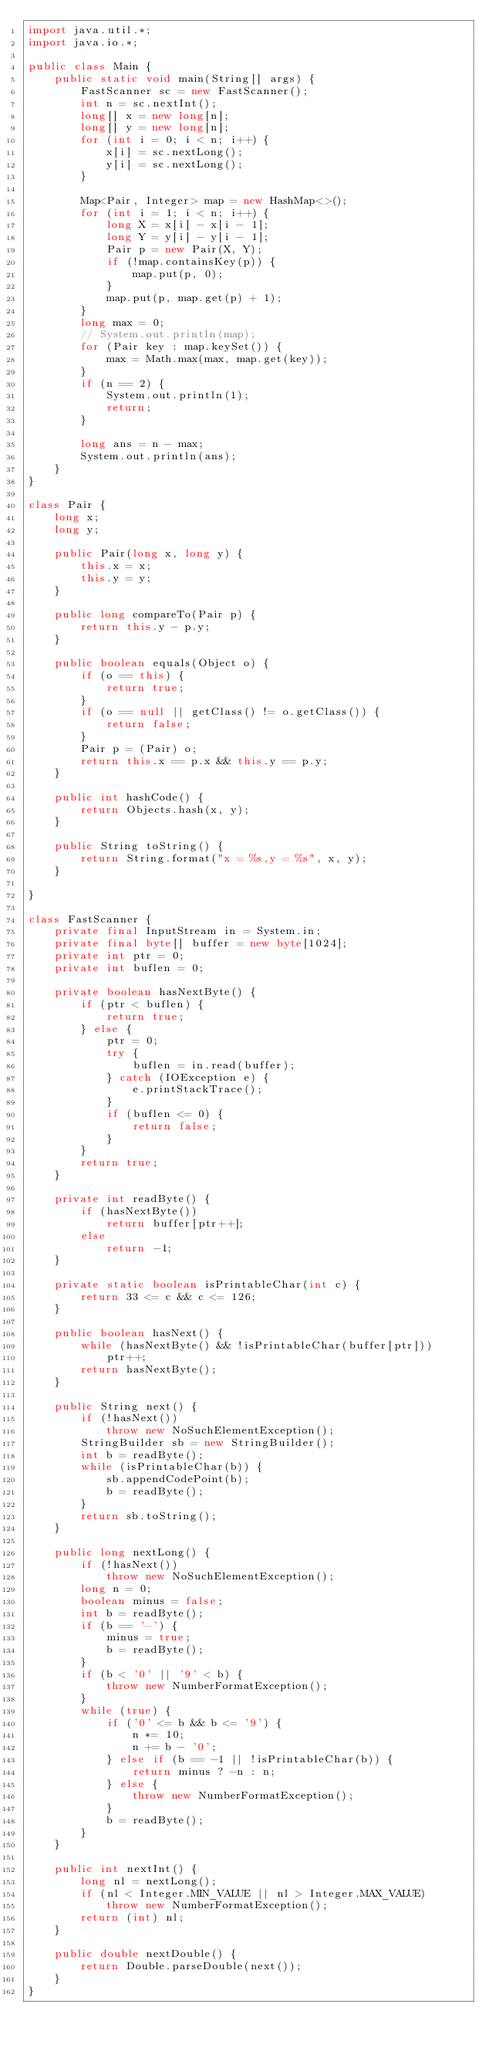Convert code to text. <code><loc_0><loc_0><loc_500><loc_500><_Java_>import java.util.*;
import java.io.*;

public class Main {
    public static void main(String[] args) {
        FastScanner sc = new FastScanner();
        int n = sc.nextInt();
        long[] x = new long[n];
        long[] y = new long[n];
        for (int i = 0; i < n; i++) {
            x[i] = sc.nextLong();
            y[i] = sc.nextLong();
        }

        Map<Pair, Integer> map = new HashMap<>();
        for (int i = 1; i < n; i++) {
            long X = x[i] - x[i - 1];
            long Y = y[i] - y[i - 1];
            Pair p = new Pair(X, Y);
            if (!map.containsKey(p)) {
                map.put(p, 0);
            }
            map.put(p, map.get(p) + 1);
        }
        long max = 0;
        // System.out.println(map);
        for (Pair key : map.keySet()) {
            max = Math.max(max, map.get(key));
        }
        if (n == 2) {
            System.out.println(1);
            return;
        }

        long ans = n - max;
        System.out.println(ans);
    }
}

class Pair {
    long x;
    long y;

    public Pair(long x, long y) {
        this.x = x;
        this.y = y;
    }

    public long compareTo(Pair p) {
        return this.y - p.y;
    }

    public boolean equals(Object o) {
        if (o == this) {
            return true;
        }
        if (o == null || getClass() != o.getClass()) {
            return false;
        }
        Pair p = (Pair) o;
        return this.x == p.x && this.y == p.y;
    }

    public int hashCode() {
        return Objects.hash(x, y);
    }

    public String toString() {
        return String.format("x = %s,y = %s", x, y);
    }

}

class FastScanner {
    private final InputStream in = System.in;
    private final byte[] buffer = new byte[1024];
    private int ptr = 0;
    private int buflen = 0;

    private boolean hasNextByte() {
        if (ptr < buflen) {
            return true;
        } else {
            ptr = 0;
            try {
                buflen = in.read(buffer);
            } catch (IOException e) {
                e.printStackTrace();
            }
            if (buflen <= 0) {
                return false;
            }
        }
        return true;
    }

    private int readByte() {
        if (hasNextByte())
            return buffer[ptr++];
        else
            return -1;
    }

    private static boolean isPrintableChar(int c) {
        return 33 <= c && c <= 126;
    }

    public boolean hasNext() {
        while (hasNextByte() && !isPrintableChar(buffer[ptr]))
            ptr++;
        return hasNextByte();
    }

    public String next() {
        if (!hasNext())
            throw new NoSuchElementException();
        StringBuilder sb = new StringBuilder();
        int b = readByte();
        while (isPrintableChar(b)) {
            sb.appendCodePoint(b);
            b = readByte();
        }
        return sb.toString();
    }

    public long nextLong() {
        if (!hasNext())
            throw new NoSuchElementException();
        long n = 0;
        boolean minus = false;
        int b = readByte();
        if (b == '-') {
            minus = true;
            b = readByte();
        }
        if (b < '0' || '9' < b) {
            throw new NumberFormatException();
        }
        while (true) {
            if ('0' <= b && b <= '9') {
                n *= 10;
                n += b - '0';
            } else if (b == -1 || !isPrintableChar(b)) {
                return minus ? -n : n;
            } else {
                throw new NumberFormatException();
            }
            b = readByte();
        }
    }

    public int nextInt() {
        long nl = nextLong();
        if (nl < Integer.MIN_VALUE || nl > Integer.MAX_VALUE)
            throw new NumberFormatException();
        return (int) nl;
    }

    public double nextDouble() {
        return Double.parseDouble(next());
    }
}
</code> 